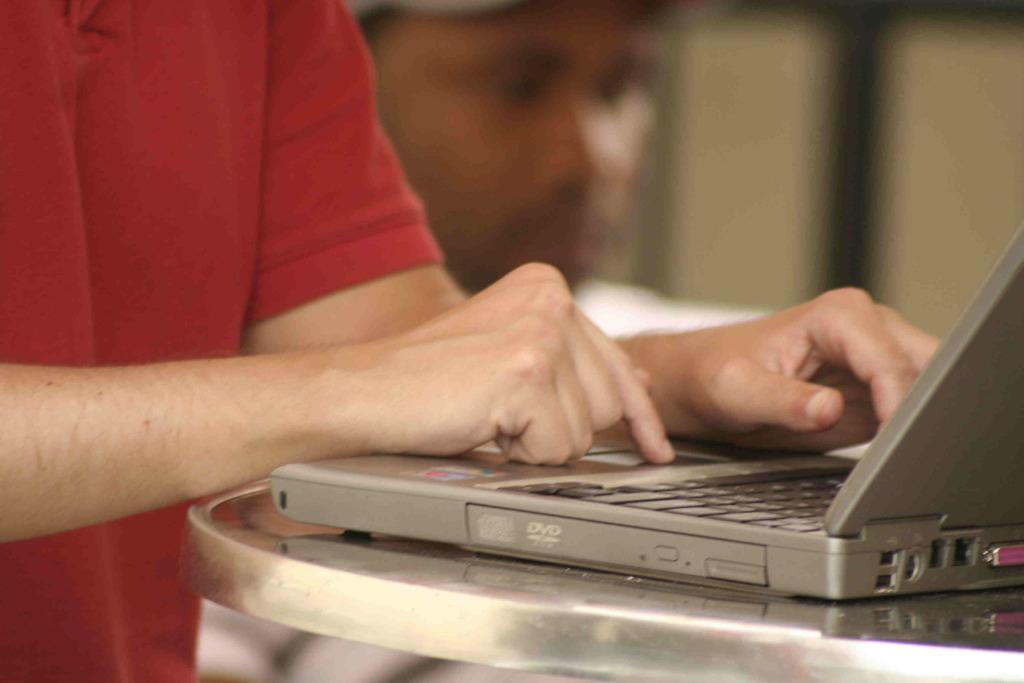<image>
Describe the image concisely. A man using a laptop with the side DVD player visible. 